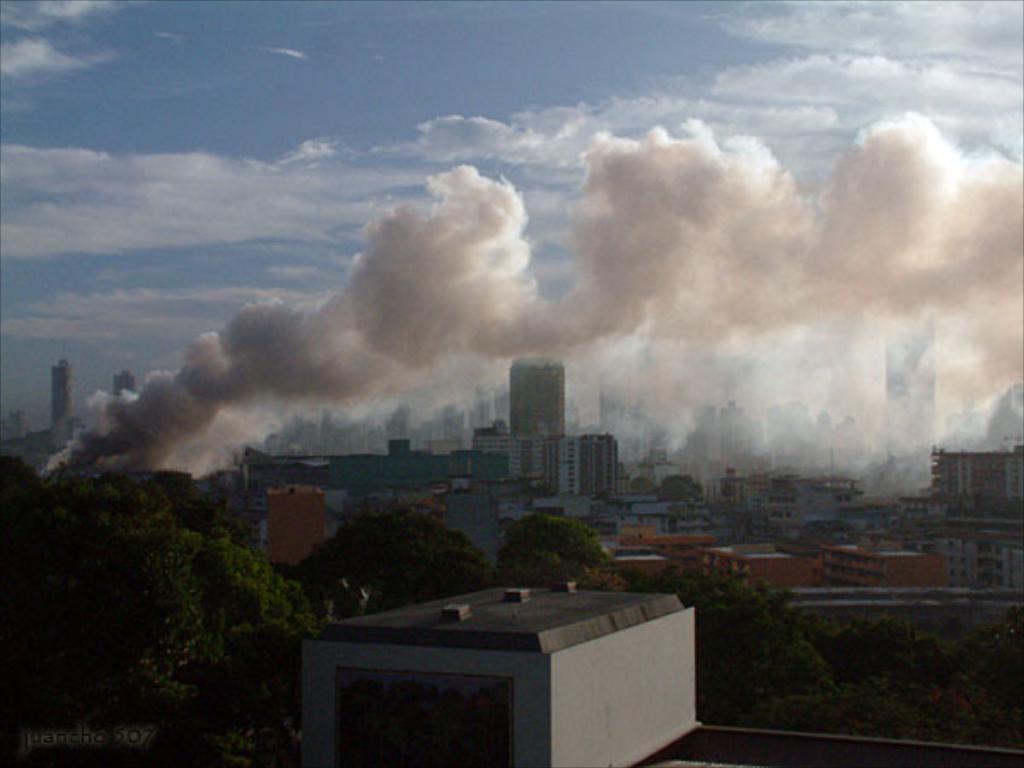Can you describe this image briefly? In this image, there are a few buildings. We can also see some trees. We can see some smoke. We can see the sky with clouds. 